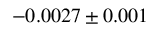Convert formula to latex. <formula><loc_0><loc_0><loc_500><loc_500>- 0 . 0 0 2 7 \pm { 0 . 0 0 1 }</formula> 